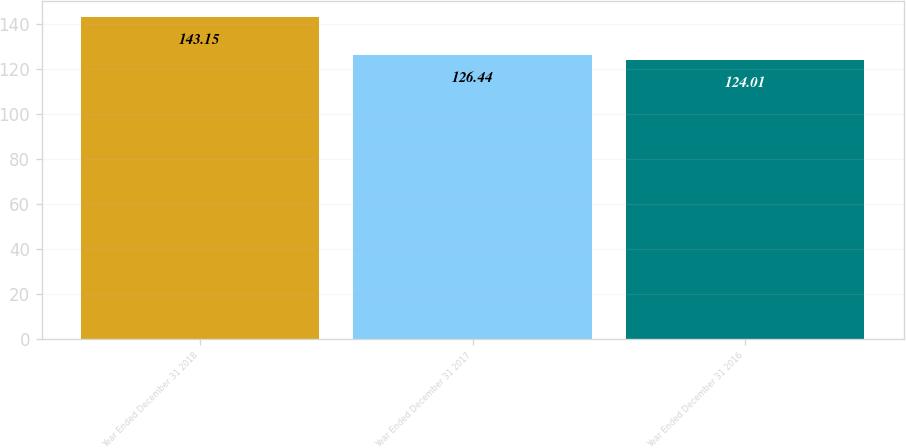Convert chart to OTSL. <chart><loc_0><loc_0><loc_500><loc_500><bar_chart><fcel>Year Ended December 31 2018<fcel>Year Ended December 31 2017<fcel>Year Ended December 31 2016<nl><fcel>143.15<fcel>126.44<fcel>124.01<nl></chart> 